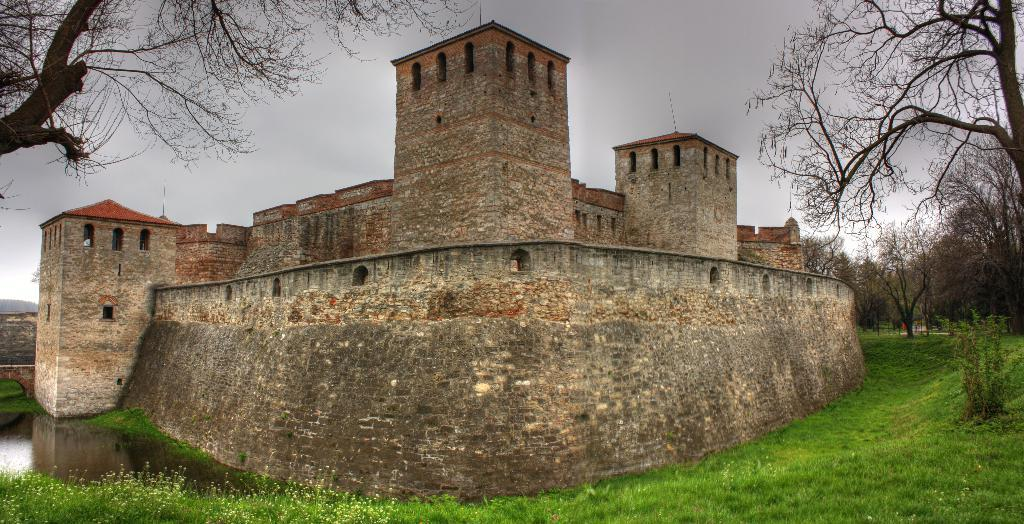What type of vegetation can be seen in the image? There is grass and flowers in the image. What natural element is present in the image? There is water in the image. What type of structure can be seen in the image? There is a fort in the image. What other type of vegetation is present in the image? There are trees in the image. What is visible in the background of the image? The sky is visible in the background of the image. How does the image show an increase in the number of masks used for bathing? The image does not show any masks or bathing activities; it features grass, flowers, water, a fort, trees, and the sky. 